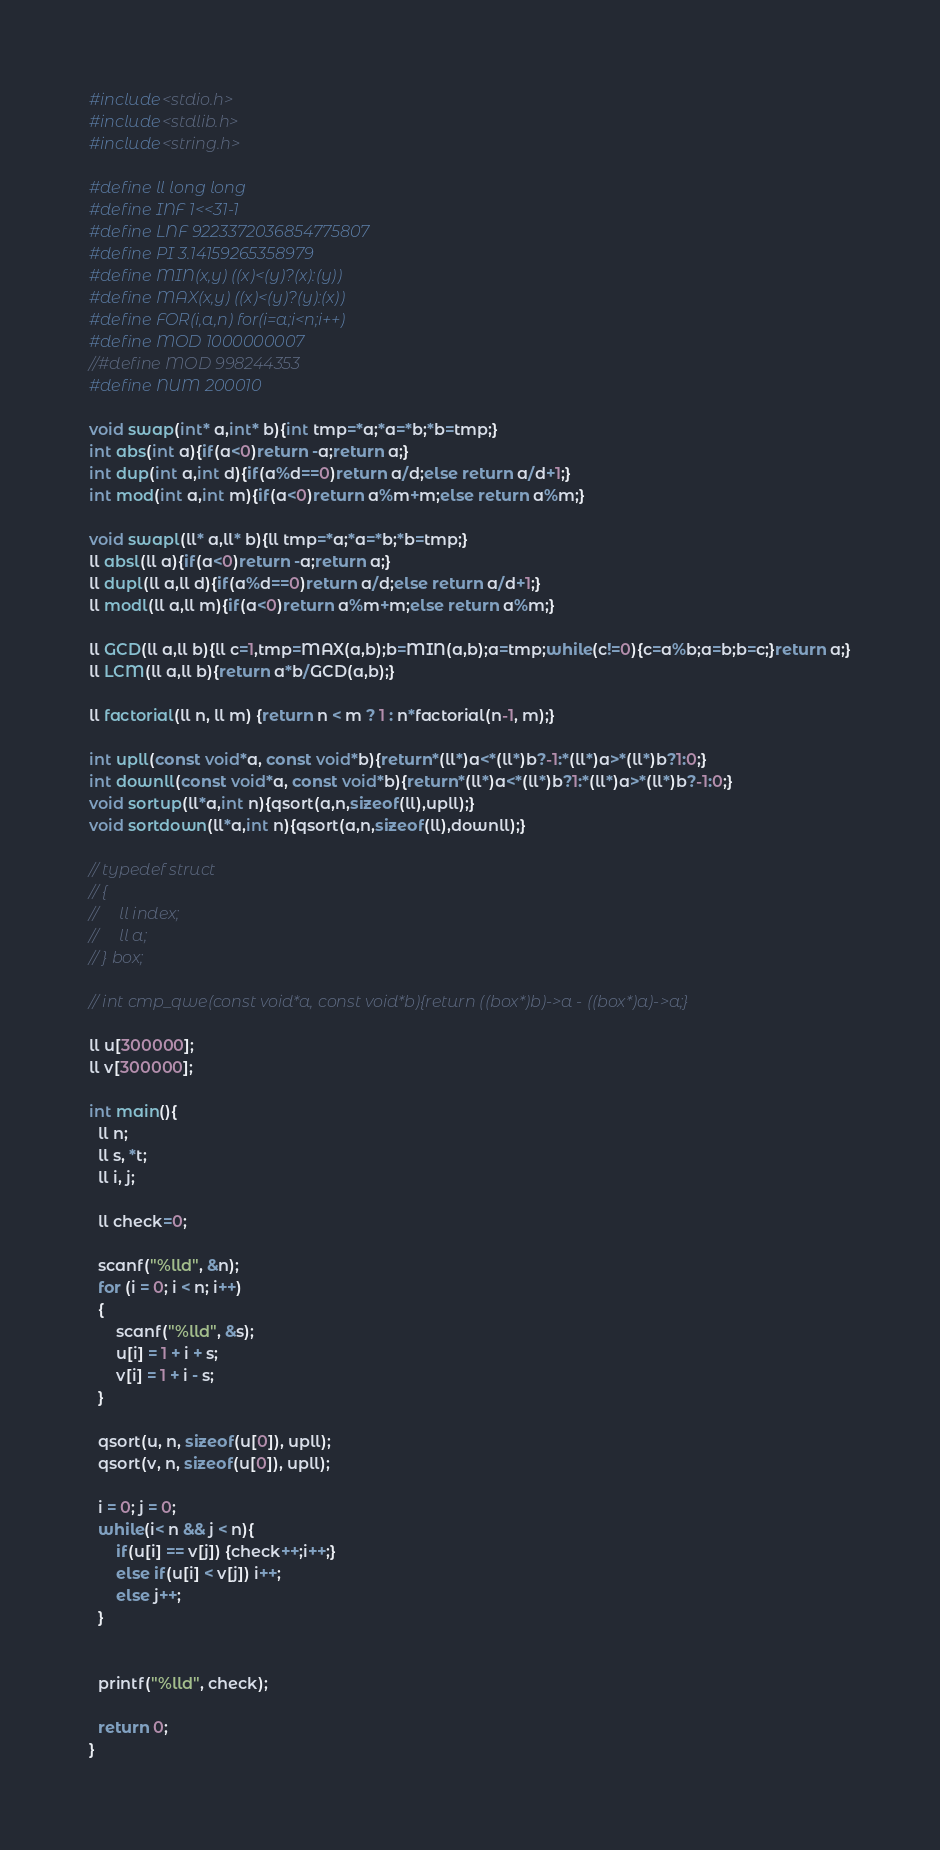Convert code to text. <code><loc_0><loc_0><loc_500><loc_500><_C_>#include<stdio.h>
#include<stdlib.h>
#include<string.h>

#define ll long long
#define INF 1<<31-1
#define LNF 9223372036854775807
#define PI 3.14159265358979
#define MIN(x,y) ((x)<(y)?(x):(y))
#define MAX(x,y) ((x)<(y)?(y):(x))
#define FOR(i,a,n) for(i=a;i<n;i++)
#define MOD 1000000007
//#define MOD 998244353
#define NUM 200010
 
void swap(int* a,int* b){int tmp=*a;*a=*b;*b=tmp;}
int abs(int a){if(a<0)return -a;return a;}
int dup(int a,int d){if(a%d==0)return a/d;else return a/d+1;}
int mod(int a,int m){if(a<0)return a%m+m;else return a%m;}

void swapl(ll* a,ll* b){ll tmp=*a;*a=*b;*b=tmp;}
ll absl(ll a){if(a<0)return -a;return a;}
ll dupl(ll a,ll d){if(a%d==0)return a/d;else return a/d+1;}
ll modl(ll a,ll m){if(a<0)return a%m+m;else return a%m;}

ll GCD(ll a,ll b){ll c=1,tmp=MAX(a,b);b=MIN(a,b);a=tmp;while(c!=0){c=a%b;a=b;b=c;}return a;}
ll LCM(ll a,ll b){return a*b/GCD(a,b);}

ll factorial(ll n, ll m) {return n < m ? 1 : n*factorial(n-1, m);}

int upll(const void*a, const void*b){return*(ll*)a<*(ll*)b?-1:*(ll*)a>*(ll*)b?1:0;}
int downll(const void*a, const void*b){return*(ll*)a<*(ll*)b?1:*(ll*)a>*(ll*)b?-1:0;}
void sortup(ll*a,int n){qsort(a,n,sizeof(ll),upll);}
void sortdown(ll*a,int n){qsort(a,n,sizeof(ll),downll);}

// typedef struct 
// {
//     ll index;
//     ll a;
// } box;

// int cmp_qwe(const void*a, const void*b){return ((box*)b)->a - ((box*)a)->a;}

ll u[300000];
ll v[300000];

int main(){
  ll n;
  ll s, *t;
  ll i, j;

  ll check=0;
  
  scanf("%lld", &n);
  for (i = 0; i < n; i++)
  {
      scanf("%lld", &s);
      u[i] = 1 + i + s;
      v[i] = 1 + i - s;
  }

  qsort(u, n, sizeof(u[0]), upll);
  qsort(v, n, sizeof(u[0]), upll);
  
  i = 0; j = 0;
  while(i< n && j < n){
      if(u[i] == v[j]) {check++;i++;}
      else if(u[i] < v[j]) i++;
      else j++;
  }
  

  printf("%lld", check);

  return 0;
}</code> 